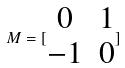<formula> <loc_0><loc_0><loc_500><loc_500>M = [ \begin{matrix} 0 & 1 \\ - 1 & 0 \end{matrix} ]</formula> 